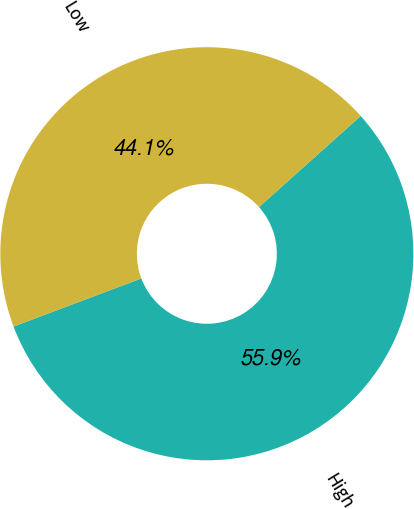Convert chart to OTSL. <chart><loc_0><loc_0><loc_500><loc_500><pie_chart><fcel>High<fcel>Low<nl><fcel>55.9%<fcel>44.1%<nl></chart> 